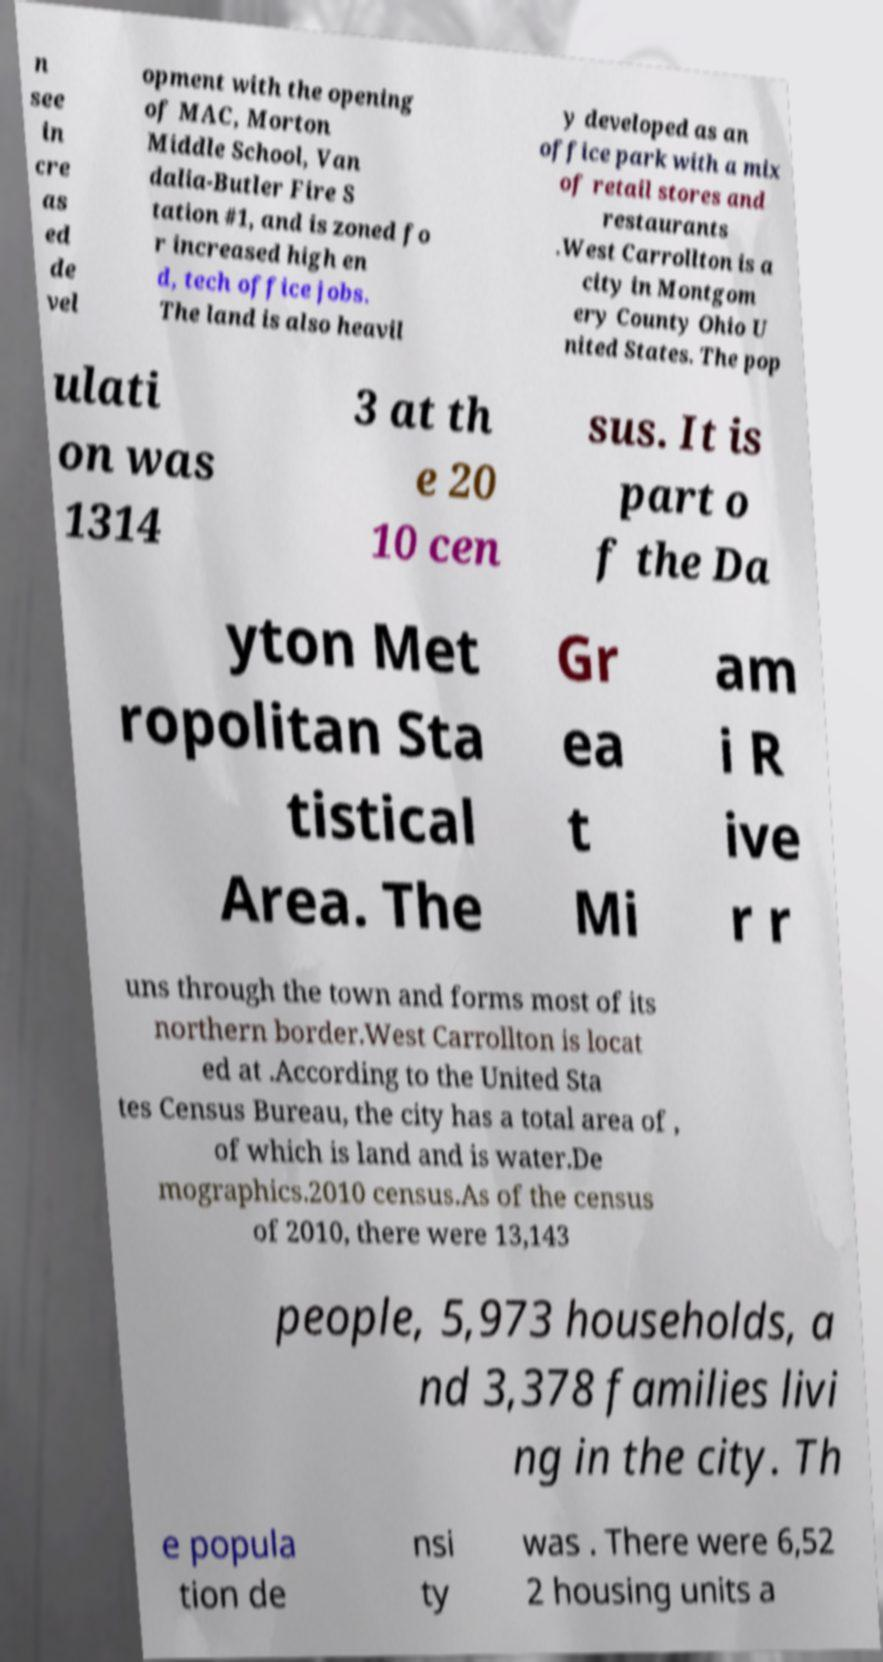What messages or text are displayed in this image? I need them in a readable, typed format. n see in cre as ed de vel opment with the opening of MAC, Morton Middle School, Van dalia-Butler Fire S tation #1, and is zoned fo r increased high en d, tech office jobs. The land is also heavil y developed as an office park with a mix of retail stores and restaurants .West Carrollton is a city in Montgom ery County Ohio U nited States. The pop ulati on was 1314 3 at th e 20 10 cen sus. It is part o f the Da yton Met ropolitan Sta tistical Area. The Gr ea t Mi am i R ive r r uns through the town and forms most of its northern border.West Carrollton is locat ed at .According to the United Sta tes Census Bureau, the city has a total area of , of which is land and is water.De mographics.2010 census.As of the census of 2010, there were 13,143 people, 5,973 households, a nd 3,378 families livi ng in the city. Th e popula tion de nsi ty was . There were 6,52 2 housing units a 